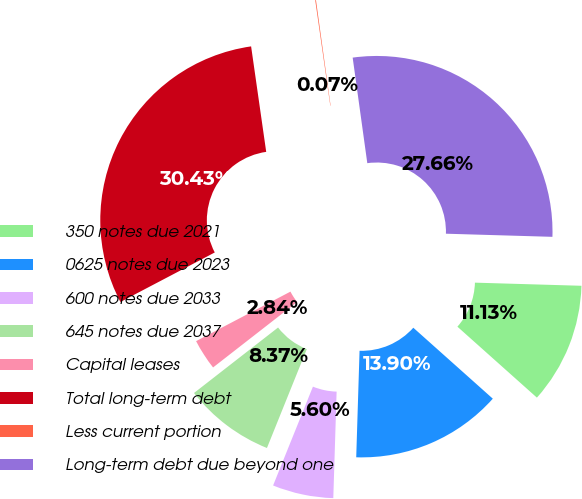Convert chart to OTSL. <chart><loc_0><loc_0><loc_500><loc_500><pie_chart><fcel>350 notes due 2021<fcel>0625 notes due 2023<fcel>600 notes due 2033<fcel>645 notes due 2037<fcel>Capital leases<fcel>Total long-term debt<fcel>Less current portion<fcel>Long-term debt due beyond one<nl><fcel>11.13%<fcel>13.9%<fcel>5.6%<fcel>8.37%<fcel>2.84%<fcel>30.43%<fcel>0.07%<fcel>27.66%<nl></chart> 